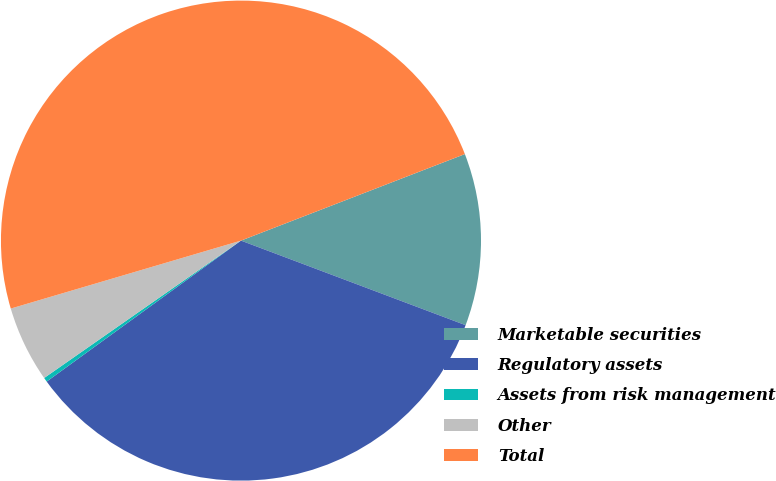<chart> <loc_0><loc_0><loc_500><loc_500><pie_chart><fcel>Marketable securities<fcel>Regulatory assets<fcel>Assets from risk management<fcel>Other<fcel>Total<nl><fcel>11.6%<fcel>34.28%<fcel>0.29%<fcel>5.13%<fcel>48.7%<nl></chart> 